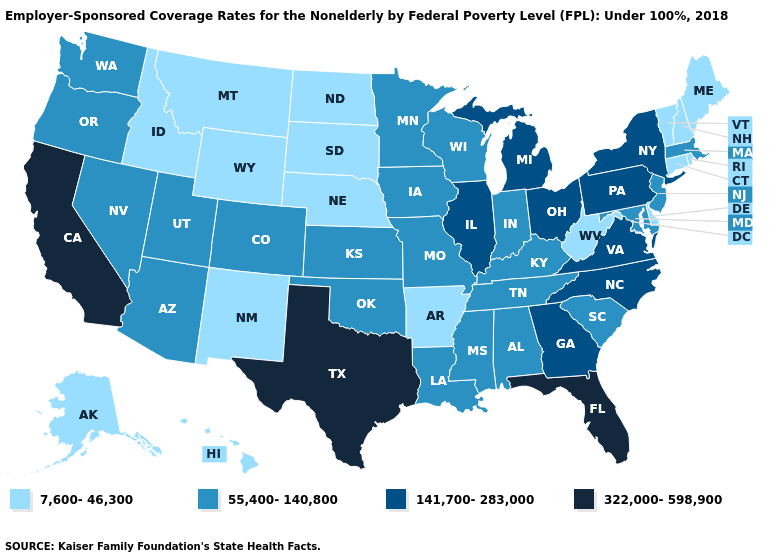What is the value of Hawaii?
Write a very short answer. 7,600-46,300. What is the value of Wisconsin?
Quick response, please. 55,400-140,800. Which states have the lowest value in the Northeast?
Concise answer only. Connecticut, Maine, New Hampshire, Rhode Island, Vermont. Does California have the lowest value in the West?
Keep it brief. No. What is the value of Pennsylvania?
Concise answer only. 141,700-283,000. Among the states that border Mississippi , which have the highest value?
Short answer required. Alabama, Louisiana, Tennessee. What is the lowest value in the West?
Quick response, please. 7,600-46,300. What is the value of South Carolina?
Keep it brief. 55,400-140,800. What is the highest value in states that border Kentucky?
Keep it brief. 141,700-283,000. Does Michigan have a lower value than Florida?
Answer briefly. Yes. Does Vermont have the lowest value in the Northeast?
Answer briefly. Yes. Which states have the highest value in the USA?
Give a very brief answer. California, Florida, Texas. Name the states that have a value in the range 55,400-140,800?
Give a very brief answer. Alabama, Arizona, Colorado, Indiana, Iowa, Kansas, Kentucky, Louisiana, Maryland, Massachusetts, Minnesota, Mississippi, Missouri, Nevada, New Jersey, Oklahoma, Oregon, South Carolina, Tennessee, Utah, Washington, Wisconsin. Does Vermont have the lowest value in the USA?
Quick response, please. Yes. 